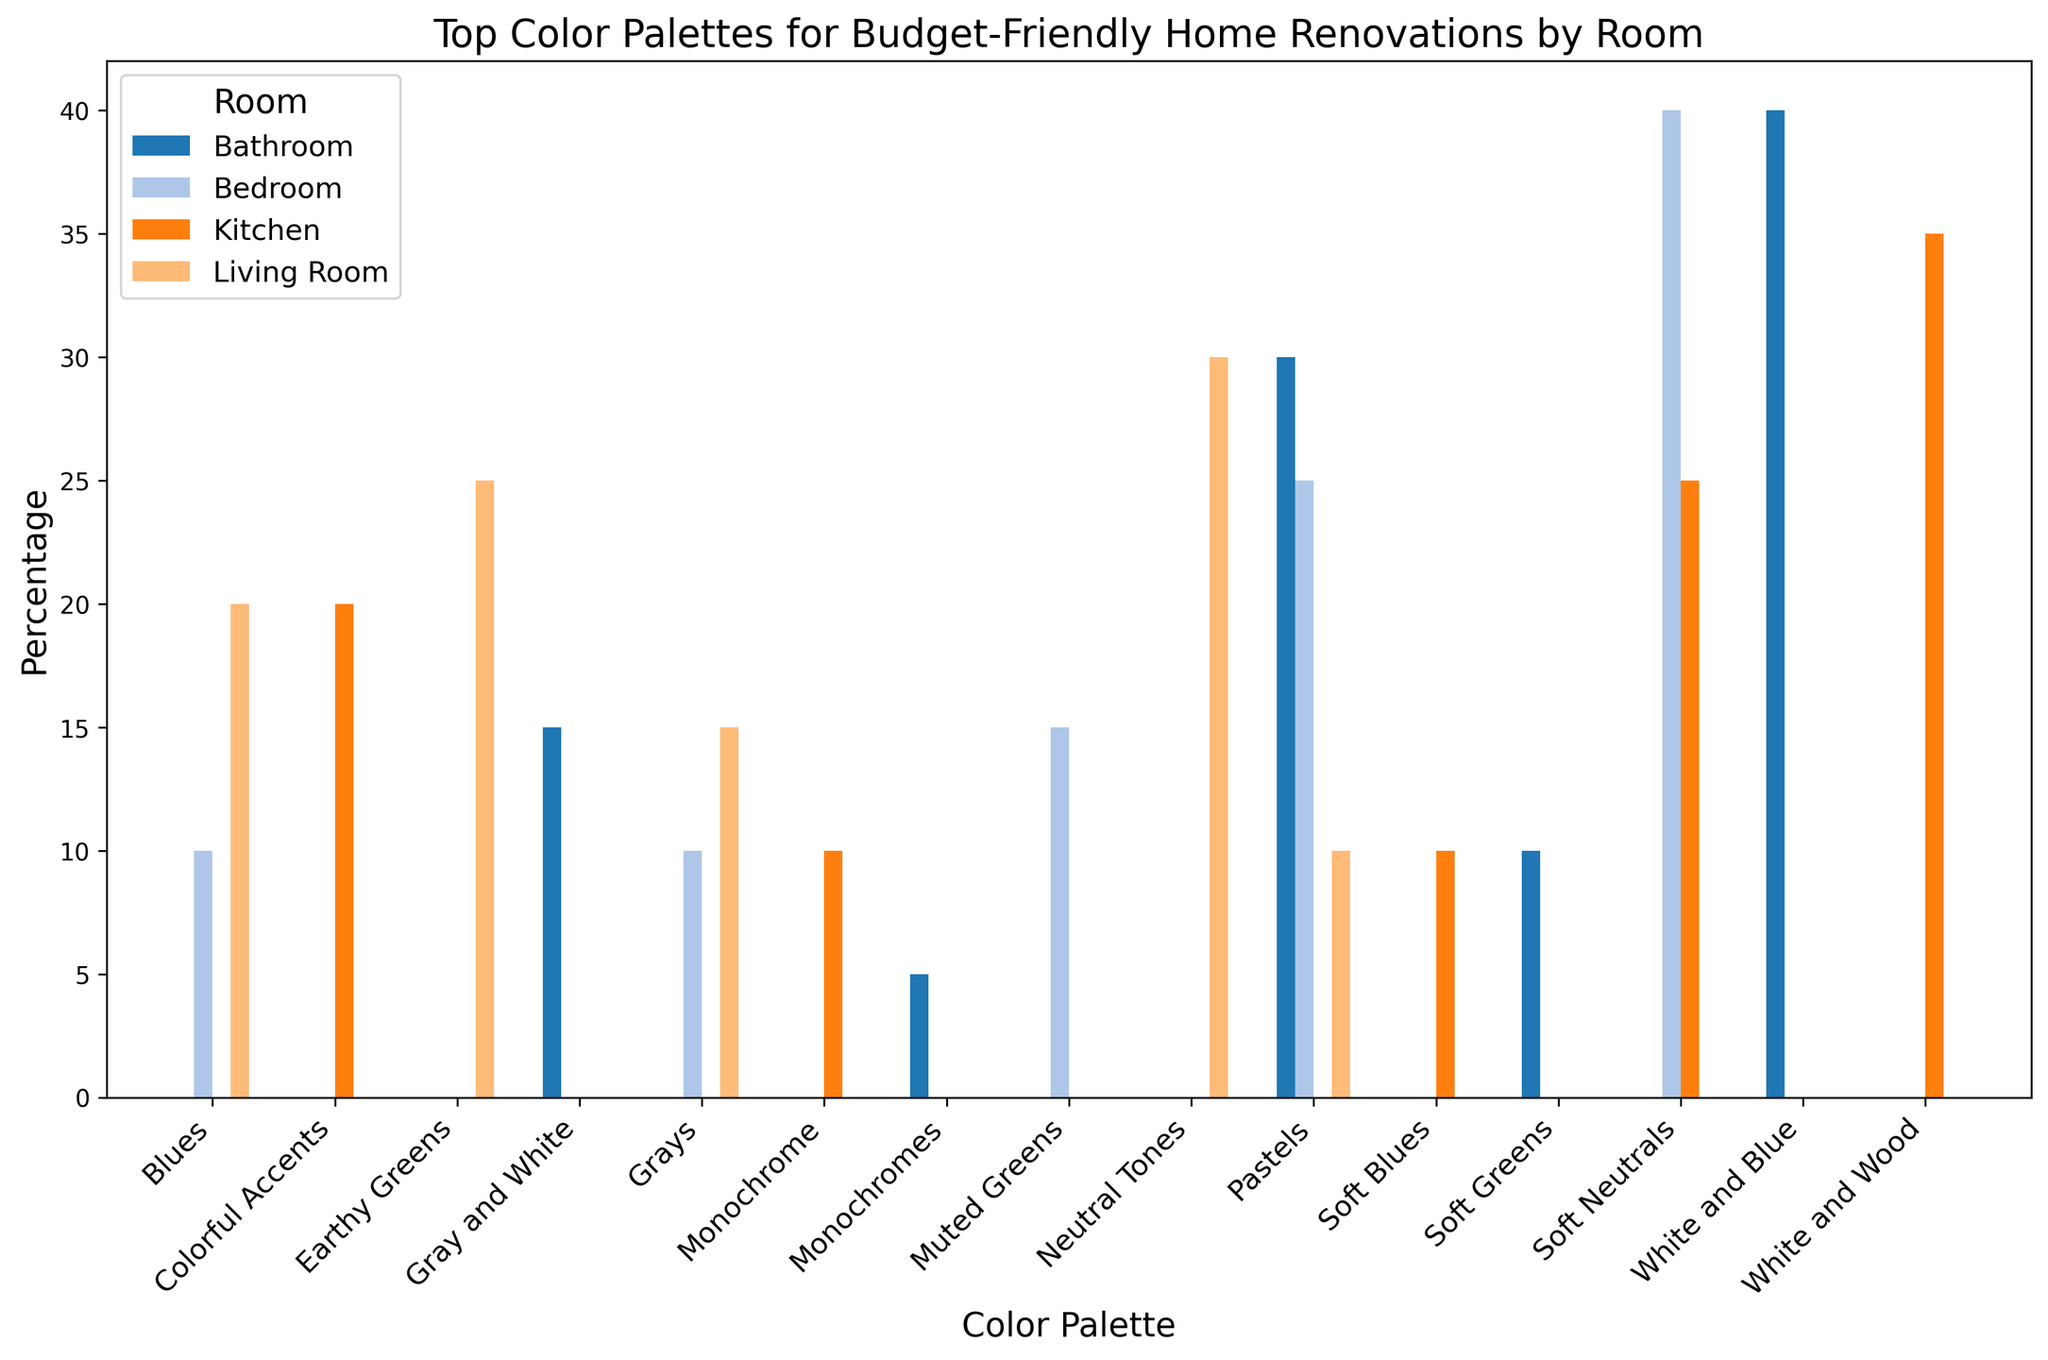What is the most chosen color palette for Living Room renovations? By looking at the tallest bar in the Living Room group, we can see that "Neutral Tones" have the highest percentage.
Answer: Neutral Tones Which room had the highest percentage for any single color palette? Identify the highest bar across all rooms, which belongs to the Kitchen for the "White and Wood" palette at 35%.
Answer: Kitchen In which room are Pastels most popular? Compare the bars for "Pastels" across all rooms and see that the highest percentage is in the Bathroom.
Answer: Bathroom What's the difference in percentage between Neutral Tones and Earthy Greens in the Living Room? From the Living Room bars, Neutral Tones are at 30% and Earthy Greens are at 25%. The difference is 30% - 25%.
Answer: 5% What is the average percentage for the top two color palettes in the Bedroom? The top two palettes in the Bedroom are Soft Neutrals (40%) and Pastels (25%), so the average is (40% + 25%) / 2.
Answer: 32.5% Which room has the lowest percentage for Monochromes? Compare the bars for "Monochromes" across rooms and see that the lowest is in the Bathroom at 5%.
Answer: Bathroom Is the percentage for Grays in the Living Room higher or lower than in the Bedroom? Compare the height of Grays bars between the Living Room (15%) and the Bedroom (10%).
Answer: Higher What is the sum of the percentages for Colorful Accents and Monochrome in the Kitchen? Add the percentages for "Colorful Accents" (20%) and "Monochrome" (10%) in the Kitchen.
Answer: 30% How many color palettes in the Bathroom have a percentage of 15% or more? Count the bars in the Bathroom that meet or exceed 15%: White and Blue, Pastels, and Gray and White.
Answer: 3 Which room has the most diverse use of color palettes based on the percentage spread? Assess the distribution of bars in each room and find that Living Room has the most even spread with no single palette dominating excessively.
Answer: Living Room 